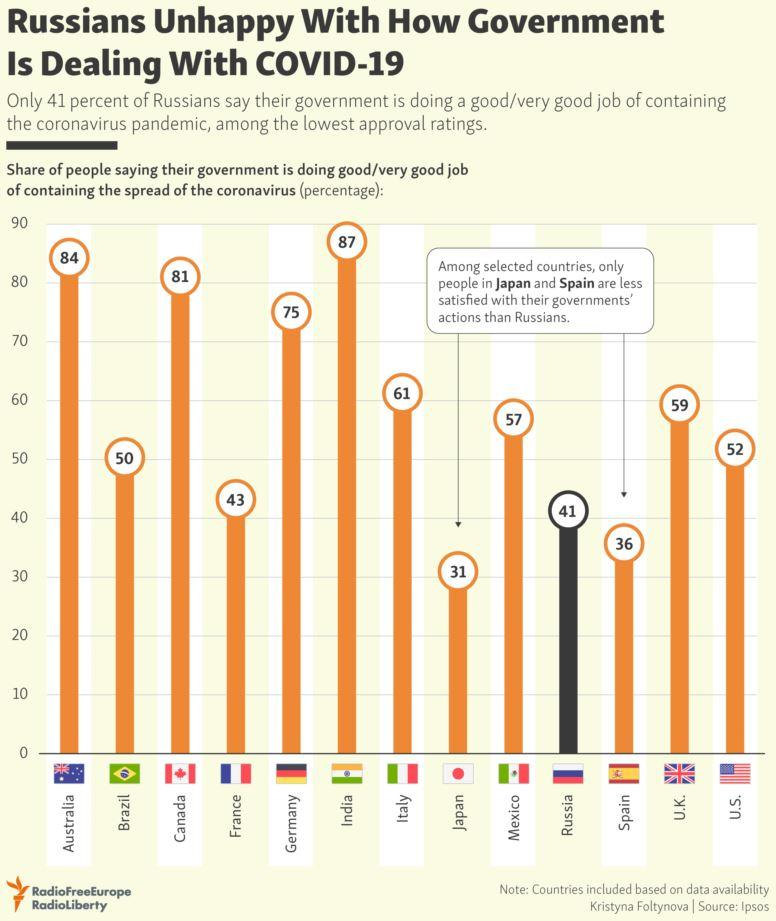List a handful of essential elements in this visual. According to a recent survey, 87% of people in India believe that their government is effectively managing the spread of the coronavirus. According to the given data, among the selected countries, Japanese and Spanish citizens are less satisfied with their governments' actions than the Russian citizens. India is the country that is most satisfied with their government's actions among the selected countries. According to a recent survey, 52% of people in the United States believe that their government is effectively managing the outbreak of the coronavirus. According to a recent survey, 75% of people in Germany believe that their government is effectively managing the outbreak of the coronavirus. 